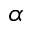<formula> <loc_0><loc_0><loc_500><loc_500>\alpha</formula> 